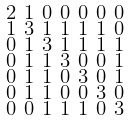<formula> <loc_0><loc_0><loc_500><loc_500>\begin{smallmatrix} 2 & 1 & 0 & 0 & 0 & 0 & 0 \\ 1 & 3 & 1 & 1 & 1 & 1 & 0 \\ 0 & 1 & 3 & 1 & 1 & 1 & 1 \\ 0 & 1 & 1 & 3 & 0 & 0 & 1 \\ 0 & 1 & 1 & 0 & 3 & 0 & 1 \\ 0 & 1 & 1 & 0 & 0 & 3 & 0 \\ 0 & 0 & 1 & 1 & 1 & 0 & 3 \end{smallmatrix}</formula> 